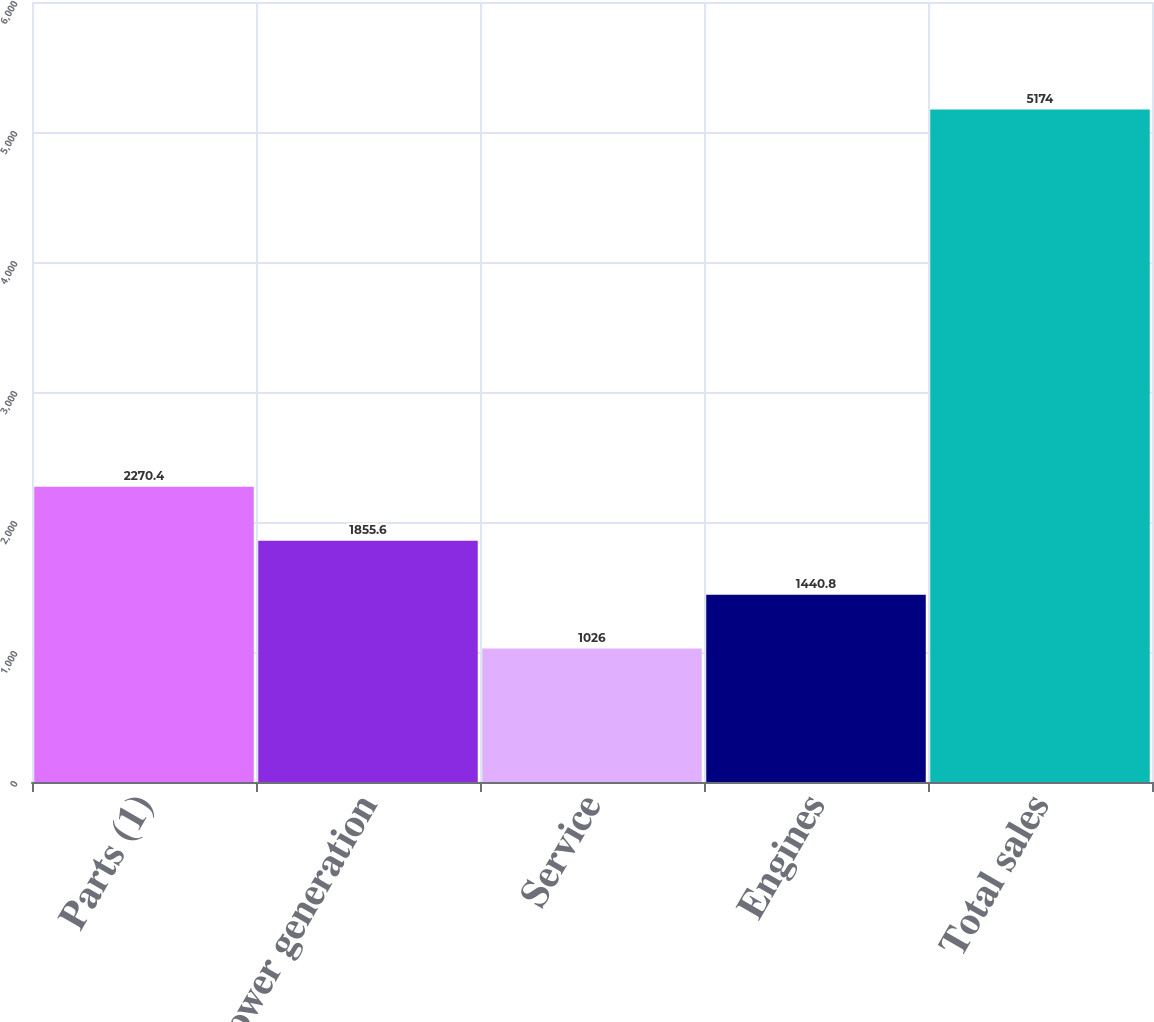<chart> <loc_0><loc_0><loc_500><loc_500><bar_chart><fcel>Parts (1)<fcel>Power generation<fcel>Service<fcel>Engines<fcel>Total sales<nl><fcel>2270.4<fcel>1855.6<fcel>1026<fcel>1440.8<fcel>5174<nl></chart> 